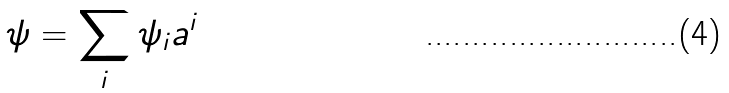<formula> <loc_0><loc_0><loc_500><loc_500>\psi = \sum _ { i } \psi _ { i } a ^ { i }</formula> 